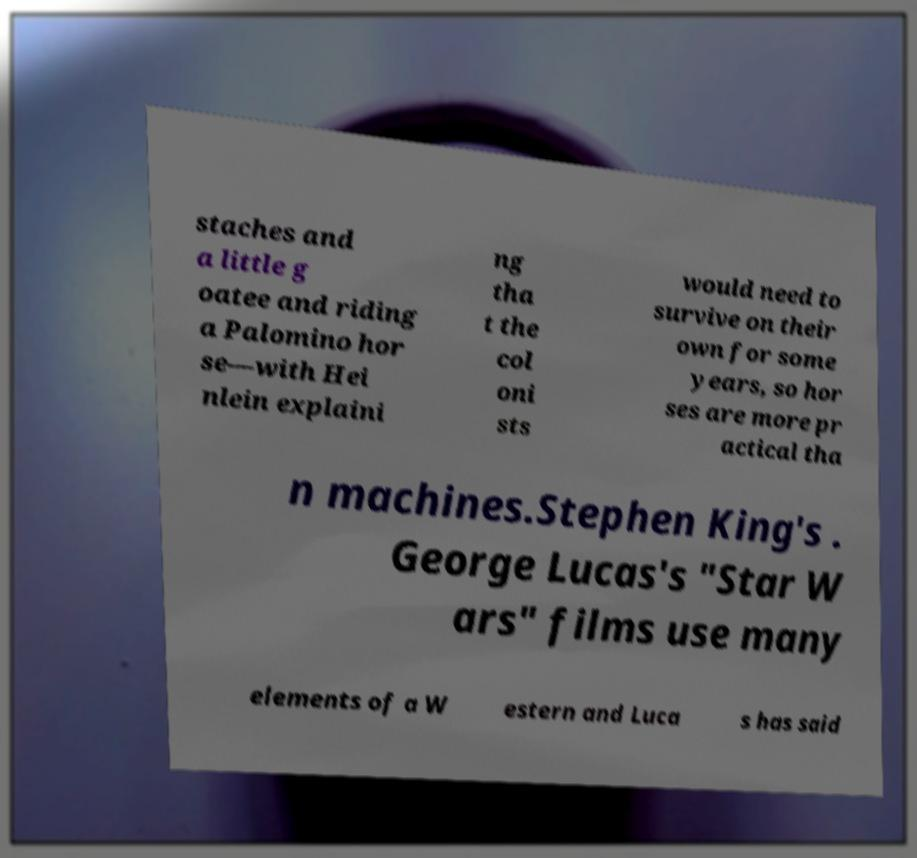For documentation purposes, I need the text within this image transcribed. Could you provide that? staches and a little g oatee and riding a Palomino hor se—with Hei nlein explaini ng tha t the col oni sts would need to survive on their own for some years, so hor ses are more pr actical tha n machines.Stephen King's . George Lucas's "Star W ars" films use many elements of a W estern and Luca s has said 